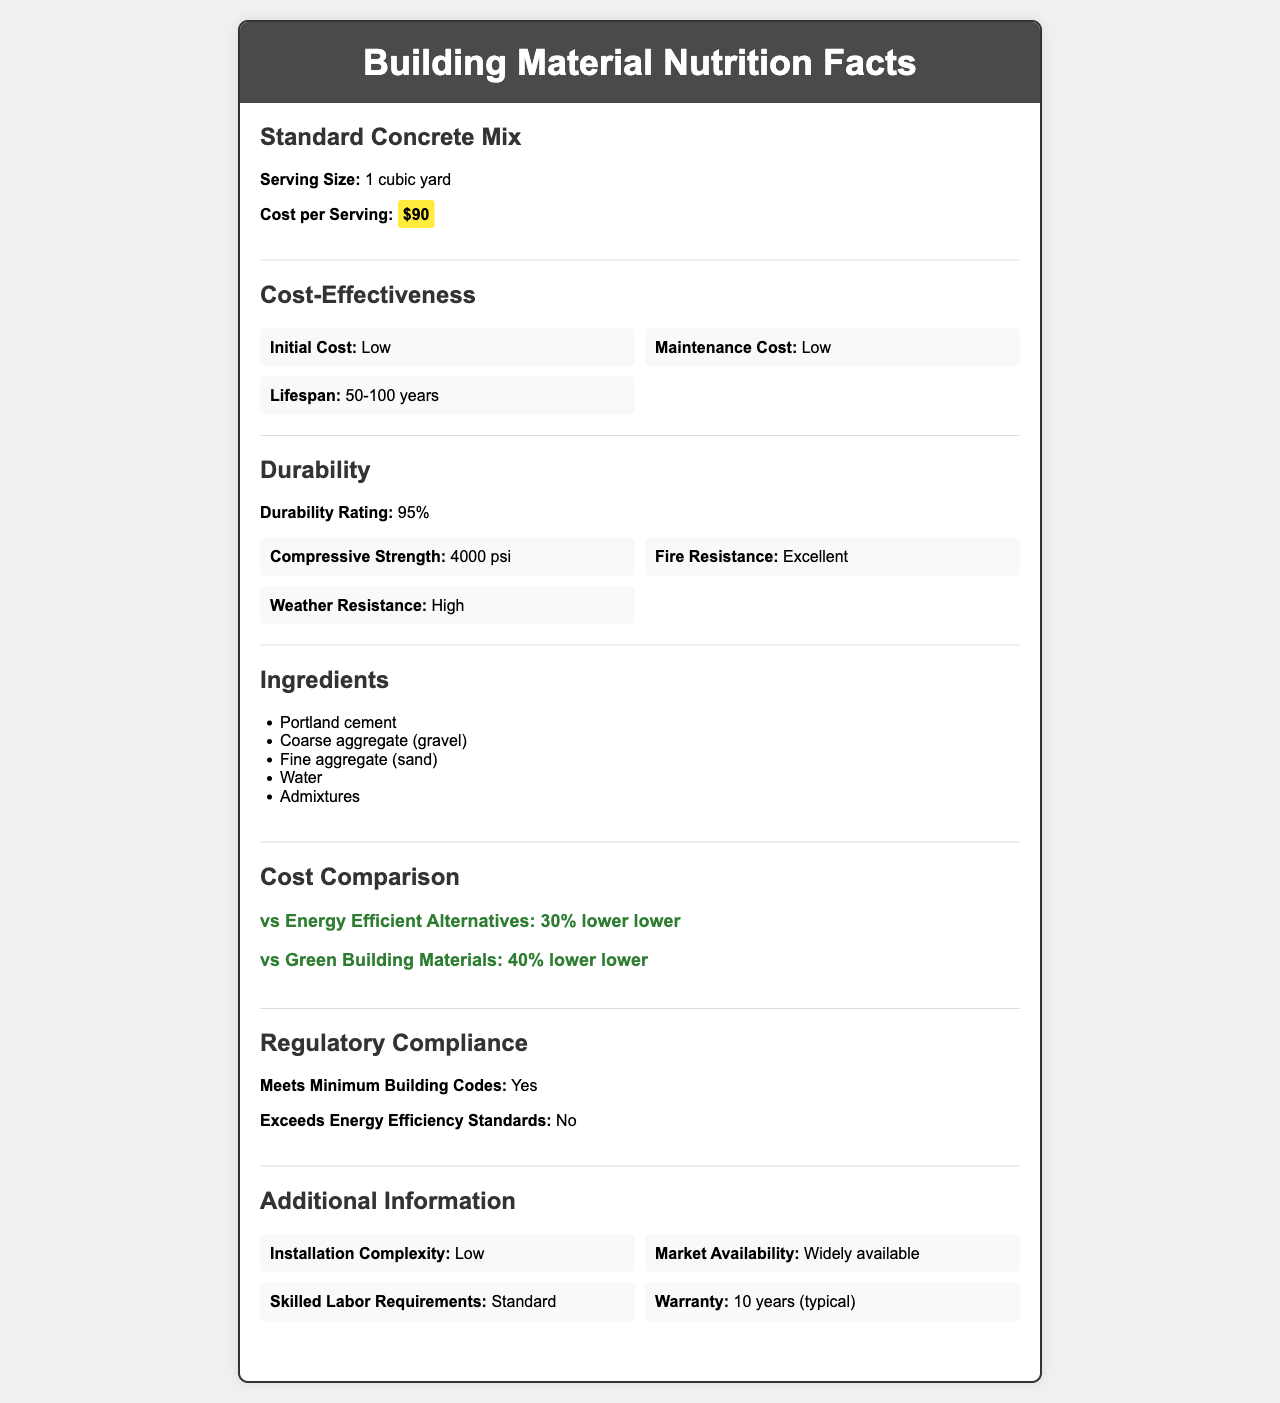How much does one cubic yard of the Standard Concrete Mix cost? The cost per serving size (1 cubic yard) of the Standard Concrete Mix is explicitly listed in the document as $90.
Answer: $90 What is the lifespan range of the Standard Concrete Mix? The document states that the lifespan of the Standard Concrete Mix is between 50 to 100 years under the cost-effectiveness section.
Answer: 50-100 years Does the Standard Concrete Mix meet minimum building codes? The regulatory compliance section confirms that the Standard Concrete Mix meets the minimum building codes.
Answer: Yes What is the compressive strength of the Standard Concrete Mix? The durability factors section lists the compressive strength as 4000 psi.
Answer: 4000 psi Name two certifications that the Standard Concrete Mix complies with? The certifications section lists ASTM C150 and ASTM C33 as the certifications the Standard Concrete Mix complies with.
Answer: ASTM C150 and ASTM C33 What are the main ingredients found in the Standard Concrete Mix? The ingredients section lists these as the main ingredients of the Standard Concrete Mix.
Answer: Portland cement, Coarse aggregate (gravel), Fine aggregate (sand), Water, Admixtures Compared to energy-efficient alternatives, how much lower is the cost of the Standard Concrete Mix? The cost comparison section states that the cost of the Standard Concrete Mix is 30% lower than energy-efficient alternatives.
Answer: 30% lower Which of the following is NOT a durability factor listed for the Standard Concrete Mix? A. Compressive Strength B. UV Resistance C. Fire Resistance D. Weather Resistance The durability factors section lists compressive strength, fire resistance, and weather resistance but does not mention UV resistance.
Answer: B. UV Resistance What is the R-value per inch of the Standard Concrete Mix? The energy efficiency section lists the R-value of the Standard Concrete Mix as 0.08 per inch.
Answer: 0.08 per inch Does the Standard Concrete Mix exceed energy efficiency standards? The regulatory compliance section clearly states that the Standard Concrete Mix does not exceed energy efficiency standards.
Answer: No Describe the overall cost-effectiveness and durability characteristics of the Standard Concrete Mix? The data combines the sections on cost-effectiveness and durability factors to detail the initial and maintenance costs, lifespan, and various durability ratings.
Answer: The Standard Concrete Mix has a low initial and maintenance cost, a lifespan of 50-100 years, and a high durability rating with excellent fire and weather resistance. What is the primary environmental impact concern of the Standard Concrete Mix? The environmental impact section lists a high carbon footprint for the Standard Concrete Mix.
Answer: High How does the Standard Concrete Mix's availability affect project timelines? The project timeline impact section states that the Standard Concrete Mix has a short procurement time, indicating it is widely available and can expedite project timelines.
Answer: It shortens procurement time. Can the installation of the Standard Concrete Mix be complex? The additional information section lists the installation complexity as low.
Answer: No Is the Standard Concrete Mix recyclable? The environmental impact section indicates that the recyclability of the Standard Concrete Mix is moderate.
Answer: Moderate What is the thermal mass of the Standard Concrete Mix? The energy efficiency section lists that the Standard Concrete Mix has a high thermal mass.
Answer: High 